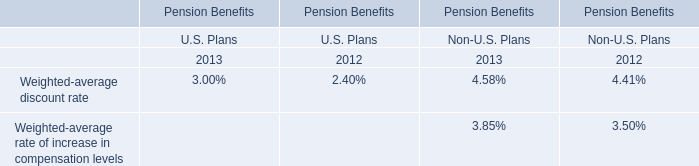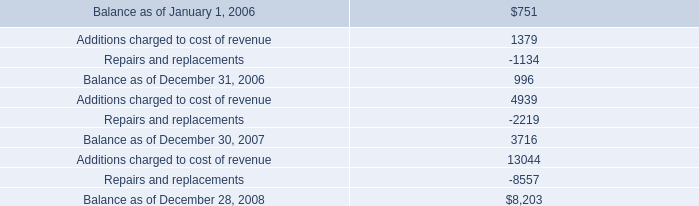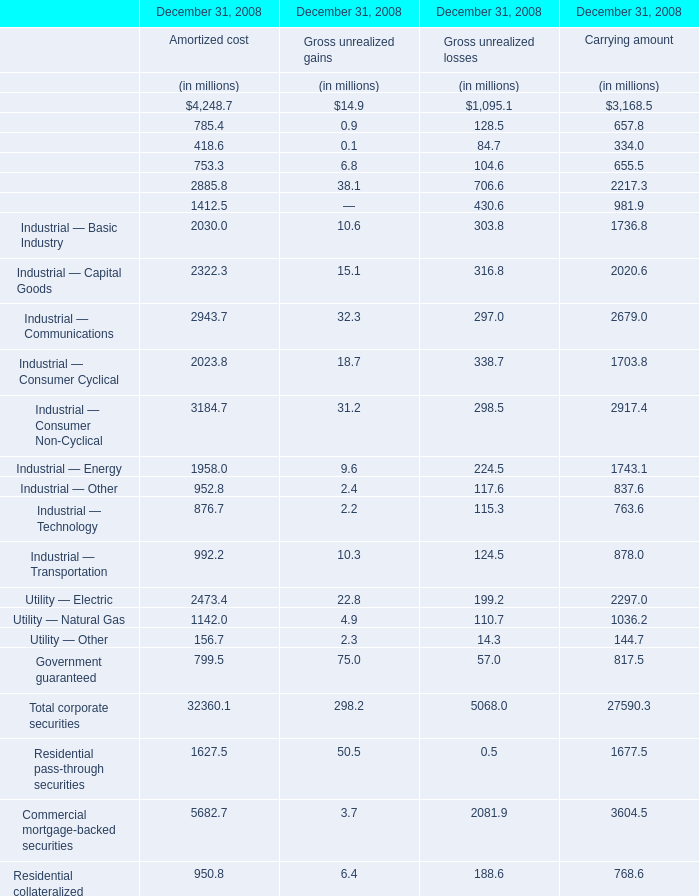What's the 10% of total elements for Gross unrealized gains in 2008? (in million) 
Computations: (486.9 * 0.1)
Answer: 48.69. 